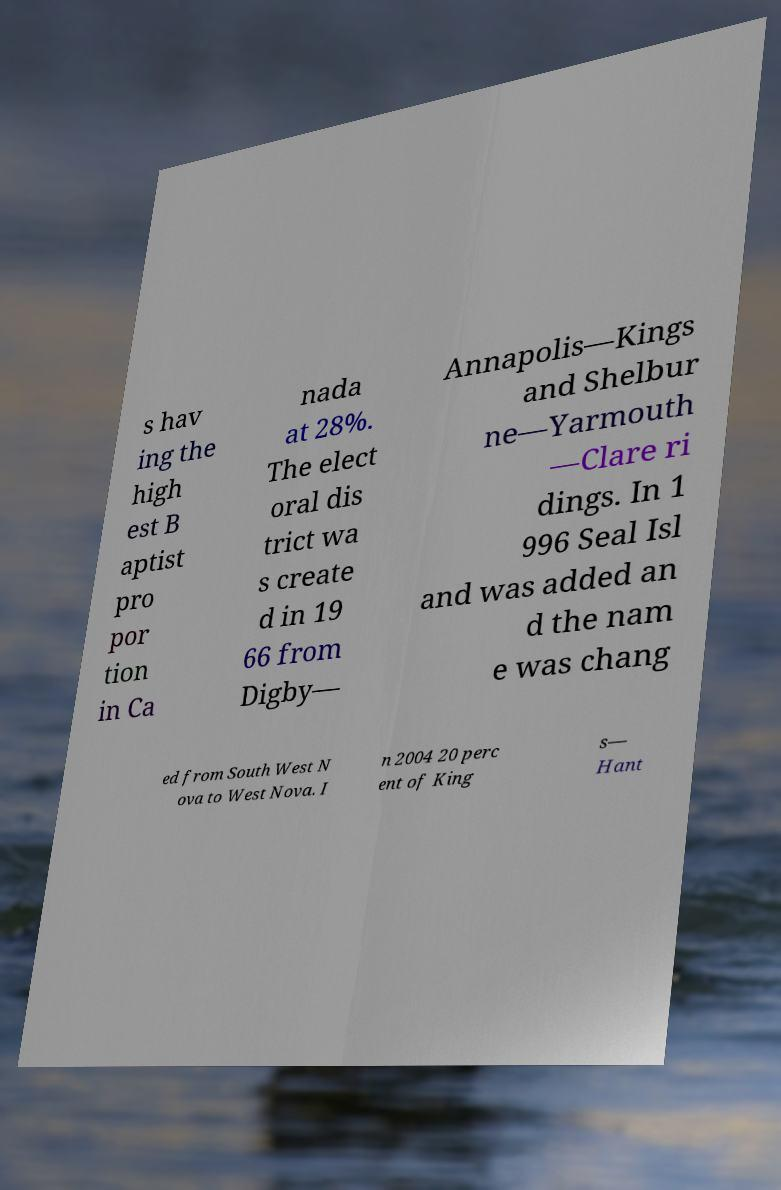Can you read and provide the text displayed in the image?This photo seems to have some interesting text. Can you extract and type it out for me? s hav ing the high est B aptist pro por tion in Ca nada at 28%. The elect oral dis trict wa s create d in 19 66 from Digby— Annapolis—Kings and Shelbur ne—Yarmouth —Clare ri dings. In 1 996 Seal Isl and was added an d the nam e was chang ed from South West N ova to West Nova. I n 2004 20 perc ent of King s— Hant 